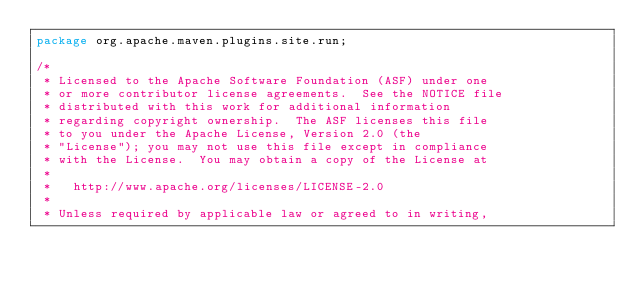<code> <loc_0><loc_0><loc_500><loc_500><_Java_>package org.apache.maven.plugins.site.run;

/*
 * Licensed to the Apache Software Foundation (ASF) under one
 * or more contributor license agreements.  See the NOTICE file
 * distributed with this work for additional information
 * regarding copyright ownership.  The ASF licenses this file
 * to you under the Apache License, Version 2.0 (the
 * "License"); you may not use this file except in compliance
 * with the License.  You may obtain a copy of the License at
 *
 *   http://www.apache.org/licenses/LICENSE-2.0
 *
 * Unless required by applicable law or agreed to in writing,</code> 